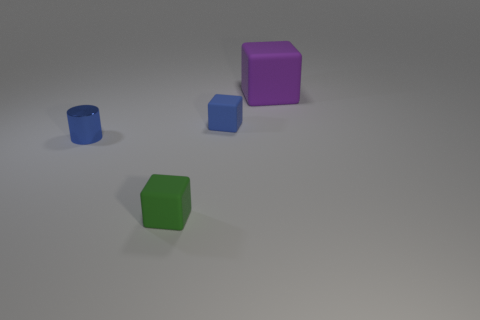Add 2 small blue metal cylinders. How many objects exist? 6 Subtract all large rubber cubes. How many cubes are left? 2 Subtract all cylinders. How many objects are left? 3 Subtract all brown cubes. Subtract all blue spheres. How many cubes are left? 3 Subtract all red cubes. How many yellow cylinders are left? 0 Subtract all objects. Subtract all gray blocks. How many objects are left? 0 Add 1 blue blocks. How many blue blocks are left? 2 Add 4 small purple balls. How many small purple balls exist? 4 Subtract 0 blue balls. How many objects are left? 4 